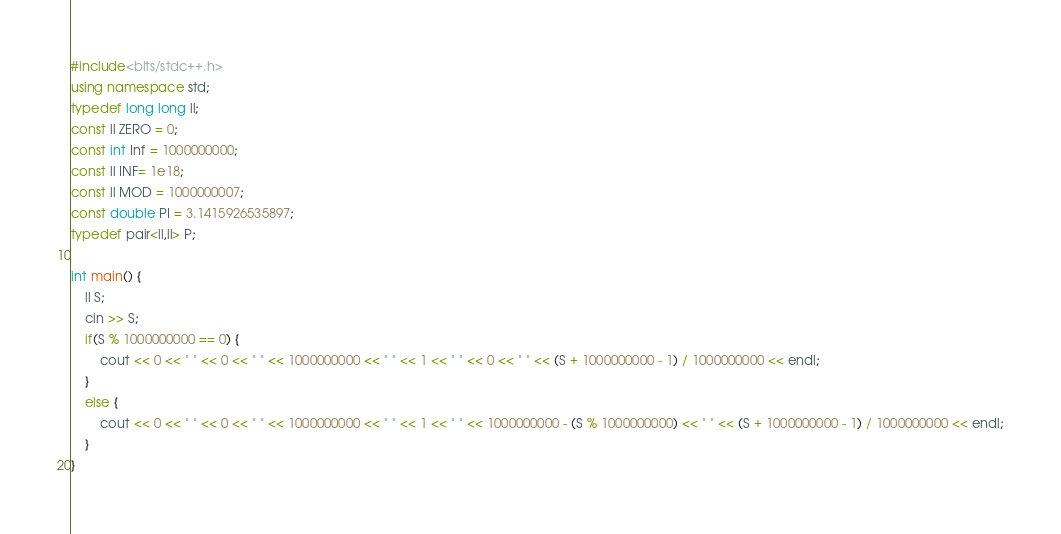<code> <loc_0><loc_0><loc_500><loc_500><_C++_>#include<bits/stdc++.h>
using namespace std;
typedef long long ll;
const ll ZERO = 0;
const int Inf = 1000000000;
const ll INF= 1e18;
const ll MOD = 1000000007;
const double PI = 3.1415926535897;
typedef pair<ll,ll> P;

int main() {
    ll S;
    cin >> S;
    if(S % 1000000000 == 0) {
        cout << 0 << " " << 0 << " " << 1000000000 << " " << 1 << " " << 0 << " " << (S + 1000000000 - 1) / 1000000000 << endl;
    }
    else {
        cout << 0 << " " << 0 << " " << 1000000000 << " " << 1 << " " << 1000000000 - (S % 1000000000) << " " << (S + 1000000000 - 1) / 1000000000 << endl;
    }
}</code> 